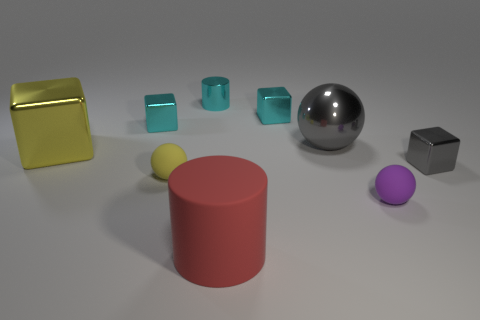Add 1 spheres. How many objects exist? 10 Subtract all balls. How many objects are left? 6 Subtract all big yellow objects. Subtract all small cyan things. How many objects are left? 5 Add 3 red rubber things. How many red rubber things are left? 4 Add 1 blue shiny cylinders. How many blue shiny cylinders exist? 1 Subtract 2 cyan cubes. How many objects are left? 7 